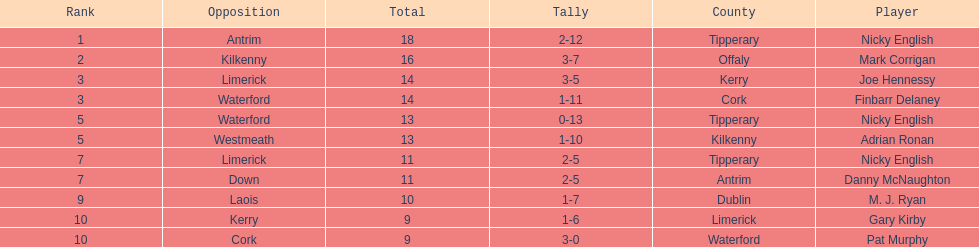Who was the top ranked player in a single game? Nicky English. 